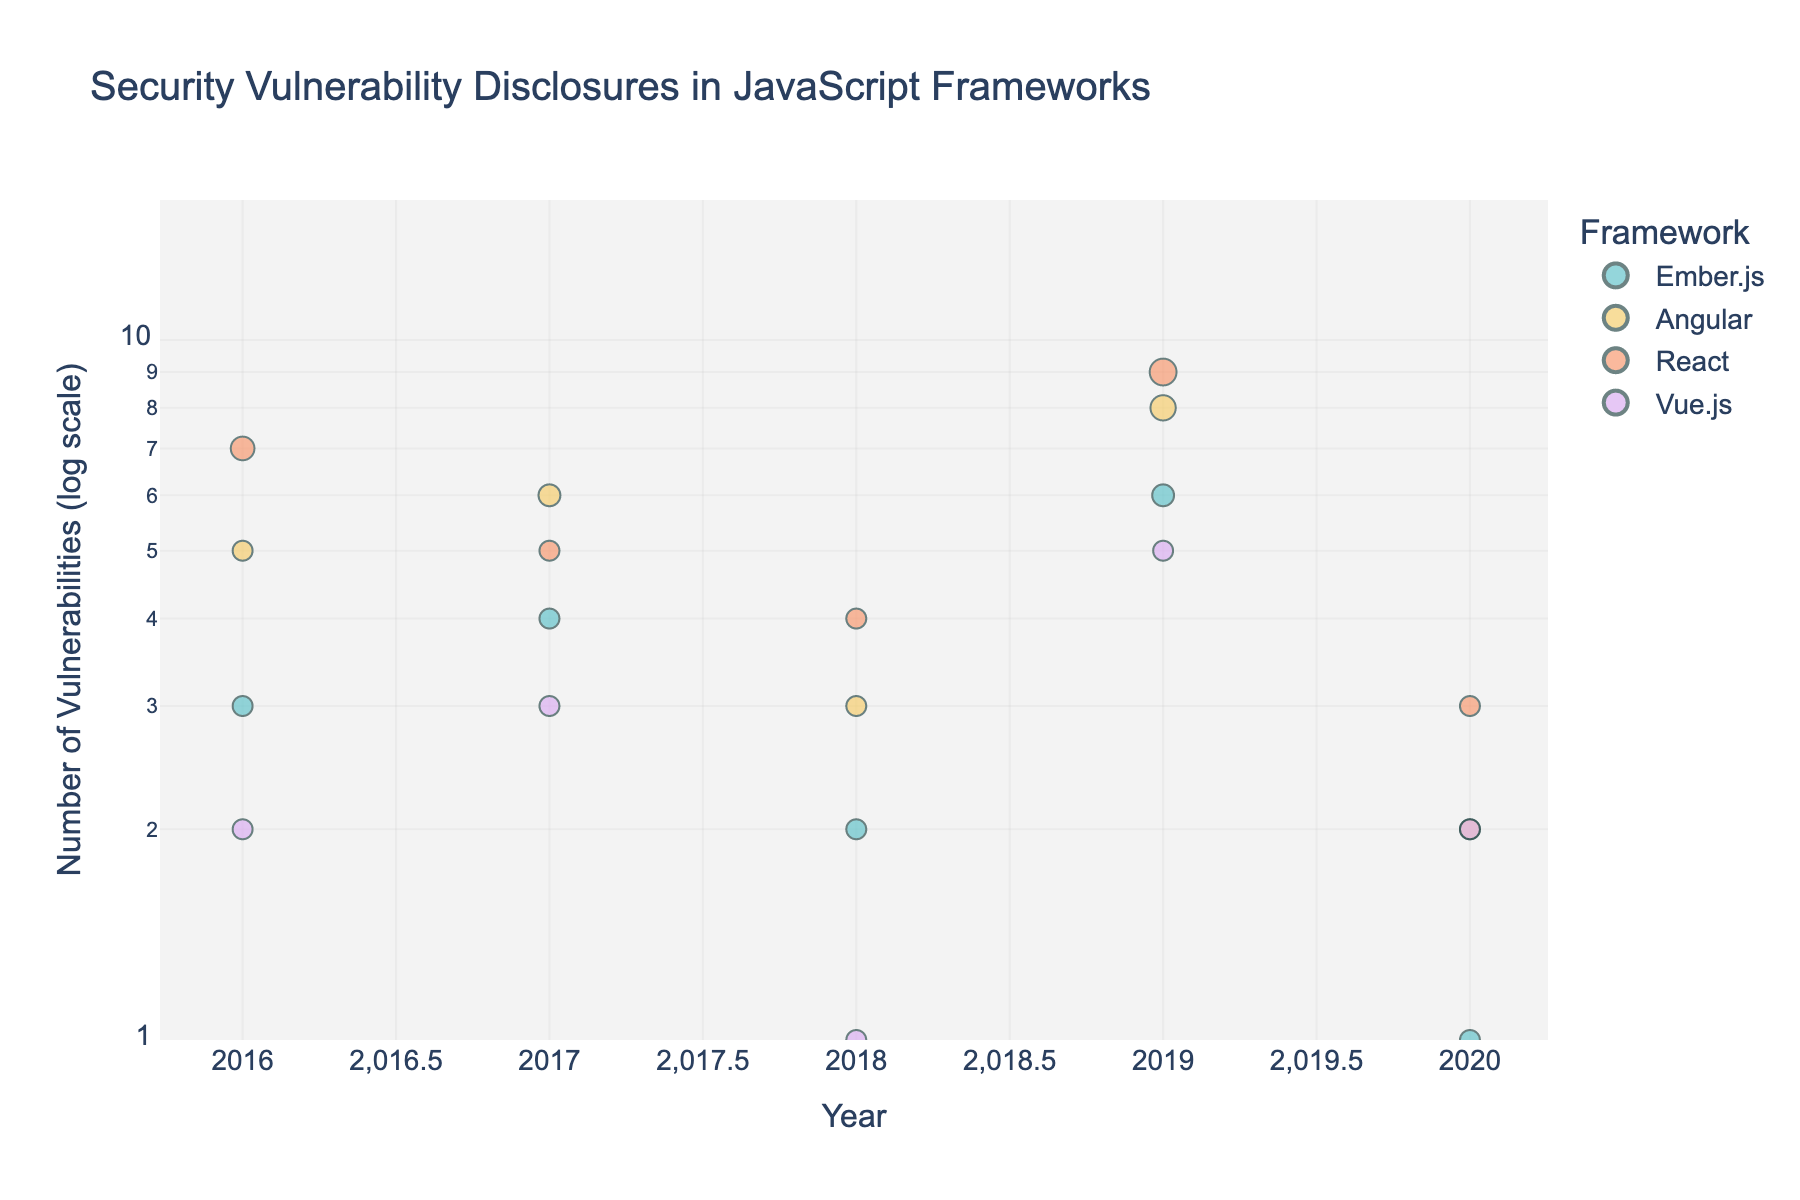How are the frameworks color-coded in the plot? Each JavaScript framework is associated with a distinct color. For example, Ember.js might be pale pink, Angular could be light blue, React might be light green, and Vue.js might be lavender. The specific color associations are displayed in the legend.
Answer: Each framework is uniquely color-coded What is the title of the figure? The title of the figure, located at the top, is "Security Vulnerability Disclosures in JavaScript Frameworks".
Answer: Security Vulnerability Disclosures in JavaScript Frameworks What is the y-axis label and its scale? The y-axis label is "Number of Vulnerabilities (log scale)", indicating that the y-axis uses a logarithmic scale to display the number of vulnerabilities.
Answer: Number of Vulnerabilities (log scale) Which framework reported the highest number of vulnerabilities in 2019? By looking at the data points for each framework in 2019, React reported the highest number of vulnerabilities (9).
Answer: React What is the trend in vulnerabilities for Ember.js from 2016 to 2020? From 2016 to 2020, Ember.js shows fluctuations in vulnerability counts. It starts with 3 vulnerabilities in 2016, increases to 4 in 2017, drops to 2 in 2018, peaks at 6 in 2019, and finally decreases to 1 in 2020.
Answer: Fluctuating with a peak in 2019 Comparing 2018 data, which framework had the fewest vulnerabilities and how many? Analyzing the data for 2018 across all frameworks, Vue.js had the fewest vulnerabilities, which was 1.
Answer: Vue.js had 1 vulnerability How does the size of the markers vary for the points at different vulnerability counts? The marker sizes in the scatter plot vary according to the vulnerability counts; points with higher vulnerability counts, such as 9 or 8, appear larger, while points with lower counts, such as 1 or 2, are smaller.
Answer: Larger for higher counts, smaller for lower counts What is the average number of vulnerabilities in 2019 across all frameworks? To find the average, sum the vulnerabilities in 2019 (Ember.js 6, Angular 8, React 9, Vue.js 5), which totals to 28. Then divide by the 4 frameworks which gives 28 / 4 = 7.
Answer: 7 Which framework had more vulnerabilities in 2017, Ember.js or Angular? For 2017, Ember.js had 4 vulnerabilities and Angular had 6 vulnerabilities. Comparing these, Angular had more vulnerabilities.
Answer: Angular In what year did Vue.js have a spike in vulnerabilities, and how many were reported that year? Vue.js experienced a spike in vulnerabilities in 2019, with a reported count of 5 vulnerabilities.
Answer: 2019 with 5 vulnerabilities 